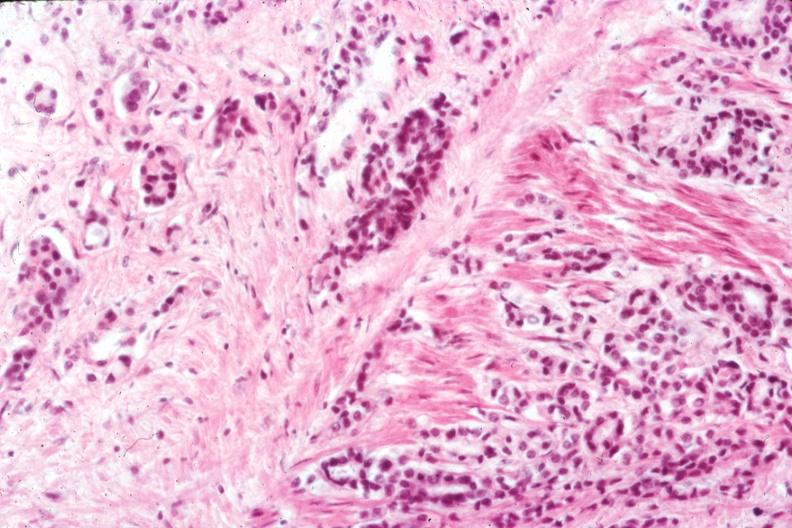what does this image show?
Answer the question using a single word or phrase. Infiltrating adenocarcinoma through smooth muscle typical for lesion 